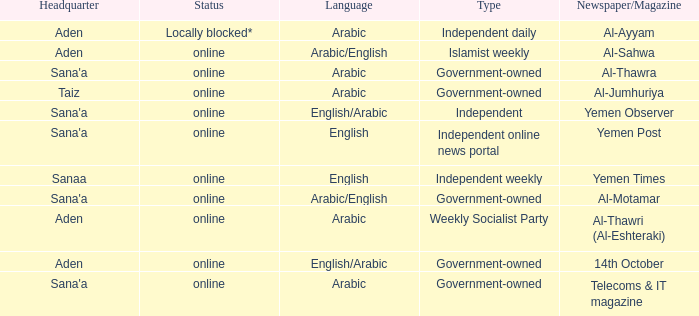Where can the main office of the al-ayyam newspaper/magazine be found? Aden. 